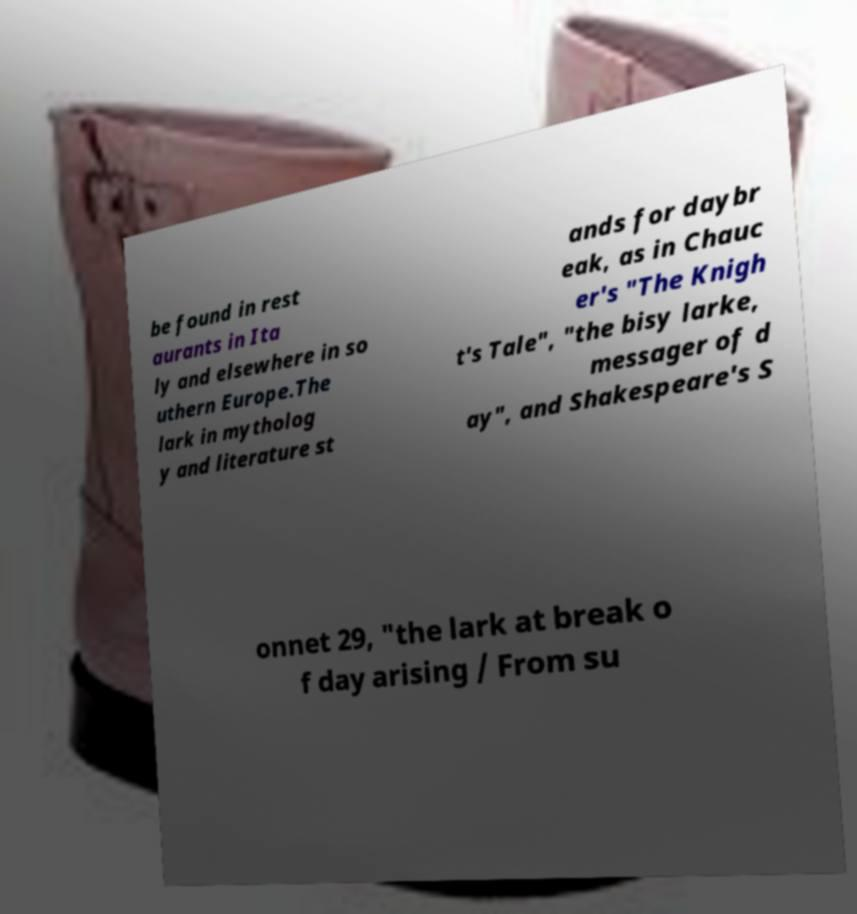Please identify and transcribe the text found in this image. be found in rest aurants in Ita ly and elsewhere in so uthern Europe.The lark in mytholog y and literature st ands for daybr eak, as in Chauc er's "The Knigh t's Tale", "the bisy larke, messager of d ay", and Shakespeare's S onnet 29, "the lark at break o f day arising / From su 